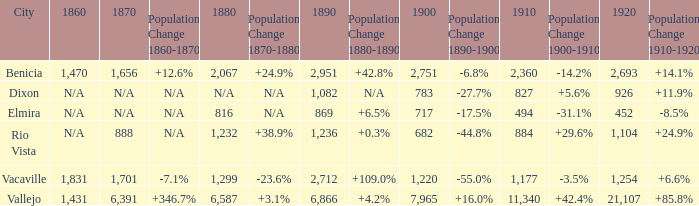What is the 1920 number when 1890 is greater than 1,236, 1910 is less than 1,177 and the city is Vacaville? None. 